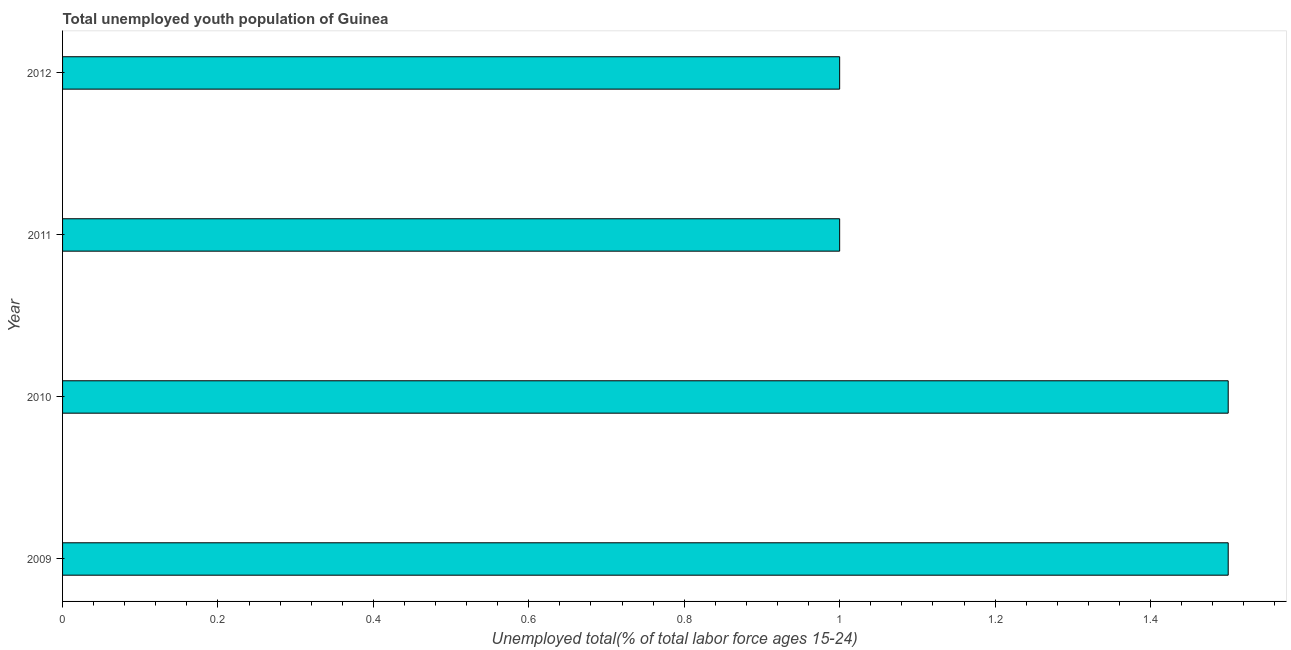Does the graph contain grids?
Provide a succinct answer. No. What is the title of the graph?
Offer a terse response. Total unemployed youth population of Guinea. What is the label or title of the X-axis?
Ensure brevity in your answer.  Unemployed total(% of total labor force ages 15-24). What is the unemployed youth in 2010?
Offer a terse response. 1.5. Across all years, what is the maximum unemployed youth?
Ensure brevity in your answer.  1.5. In which year was the unemployed youth maximum?
Offer a very short reply. 2009. In which year was the unemployed youth minimum?
Your response must be concise. 2011. What is the difference between the unemployed youth in 2009 and 2012?
Provide a succinct answer. 0.5. In how many years, is the unemployed youth greater than 0.8 %?
Your response must be concise. 4. Do a majority of the years between 2009 and 2011 (inclusive) have unemployed youth greater than 1.28 %?
Provide a short and direct response. Yes. Is the sum of the unemployed youth in 2009 and 2011 greater than the maximum unemployed youth across all years?
Keep it short and to the point. Yes. In how many years, is the unemployed youth greater than the average unemployed youth taken over all years?
Provide a succinct answer. 2. How many bars are there?
Your response must be concise. 4. Are all the bars in the graph horizontal?
Make the answer very short. Yes. How many years are there in the graph?
Provide a short and direct response. 4. What is the Unemployed total(% of total labor force ages 15-24) in 2010?
Make the answer very short. 1.5. What is the Unemployed total(% of total labor force ages 15-24) of 2012?
Offer a terse response. 1. What is the difference between the Unemployed total(% of total labor force ages 15-24) in 2009 and 2010?
Your answer should be compact. 0. What is the difference between the Unemployed total(% of total labor force ages 15-24) in 2009 and 2011?
Provide a succinct answer. 0.5. What is the difference between the Unemployed total(% of total labor force ages 15-24) in 2009 and 2012?
Provide a short and direct response. 0.5. What is the difference between the Unemployed total(% of total labor force ages 15-24) in 2010 and 2011?
Your response must be concise. 0.5. What is the difference between the Unemployed total(% of total labor force ages 15-24) in 2011 and 2012?
Give a very brief answer. 0. 